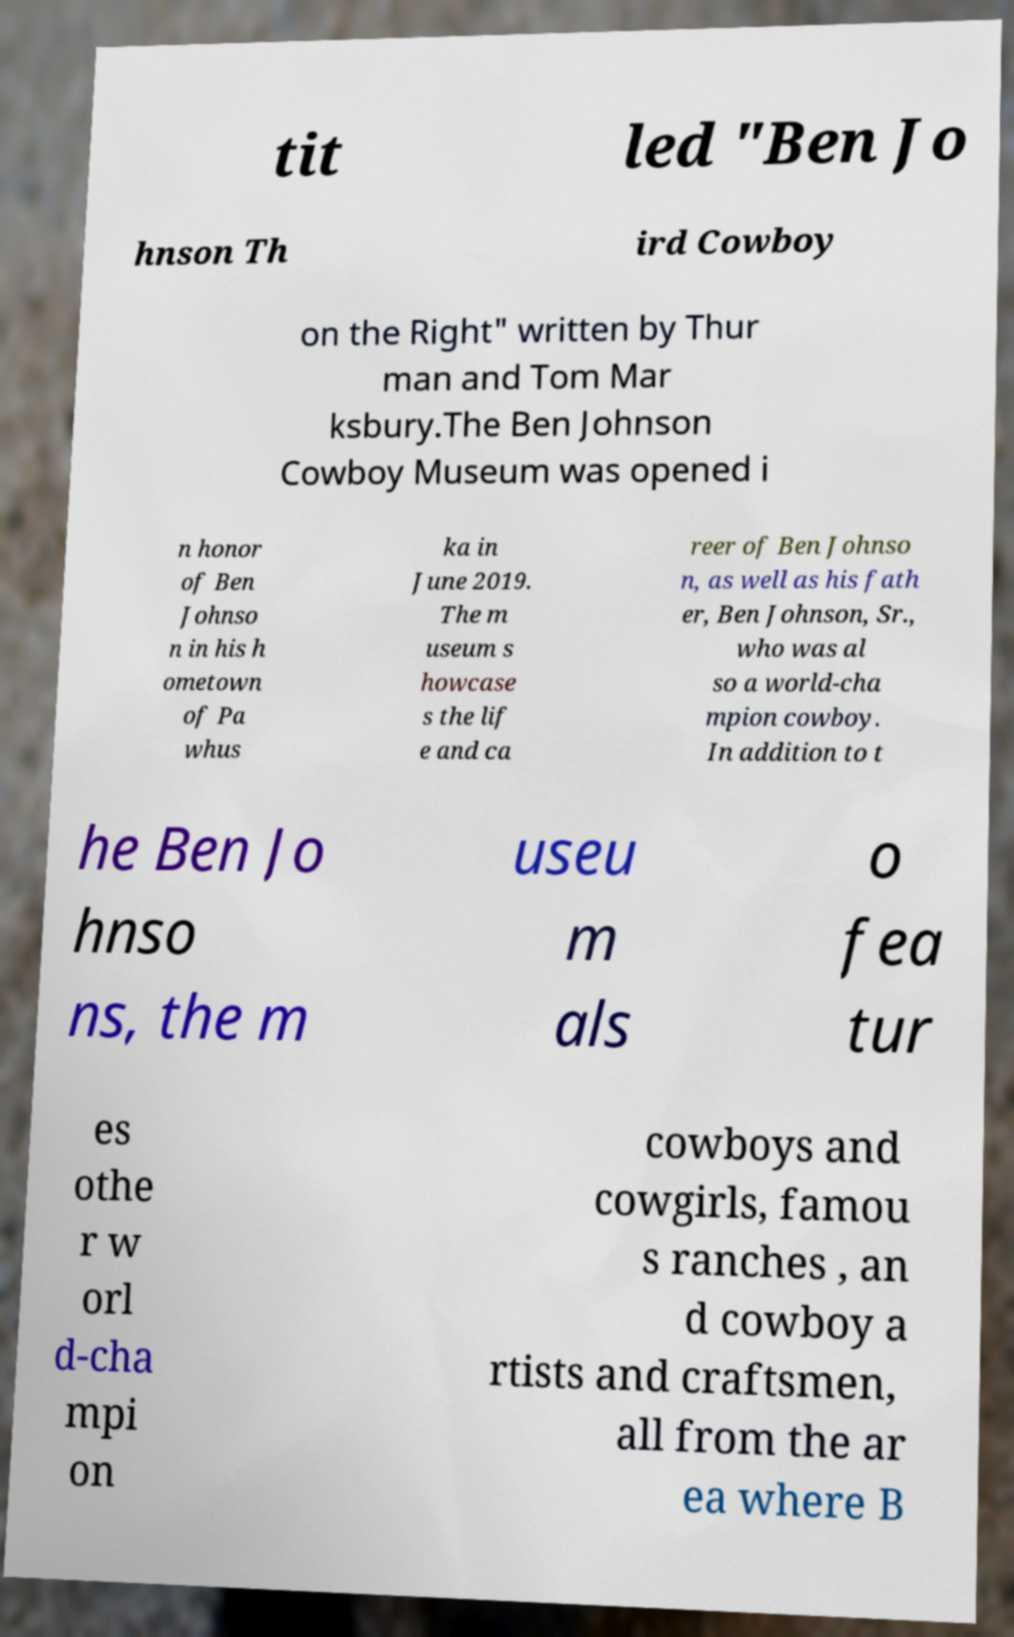Can you accurately transcribe the text from the provided image for me? tit led "Ben Jo hnson Th ird Cowboy on the Right" written by Thur man and Tom Mar ksbury.The Ben Johnson Cowboy Museum was opened i n honor of Ben Johnso n in his h ometown of Pa whus ka in June 2019. The m useum s howcase s the lif e and ca reer of Ben Johnso n, as well as his fath er, Ben Johnson, Sr., who was al so a world-cha mpion cowboy. In addition to t he Ben Jo hnso ns, the m useu m als o fea tur es othe r w orl d-cha mpi on cowboys and cowgirls, famou s ranches , an d cowboy a rtists and craftsmen, all from the ar ea where B 